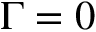Convert formula to latex. <formula><loc_0><loc_0><loc_500><loc_500>\Gamma = 0</formula> 